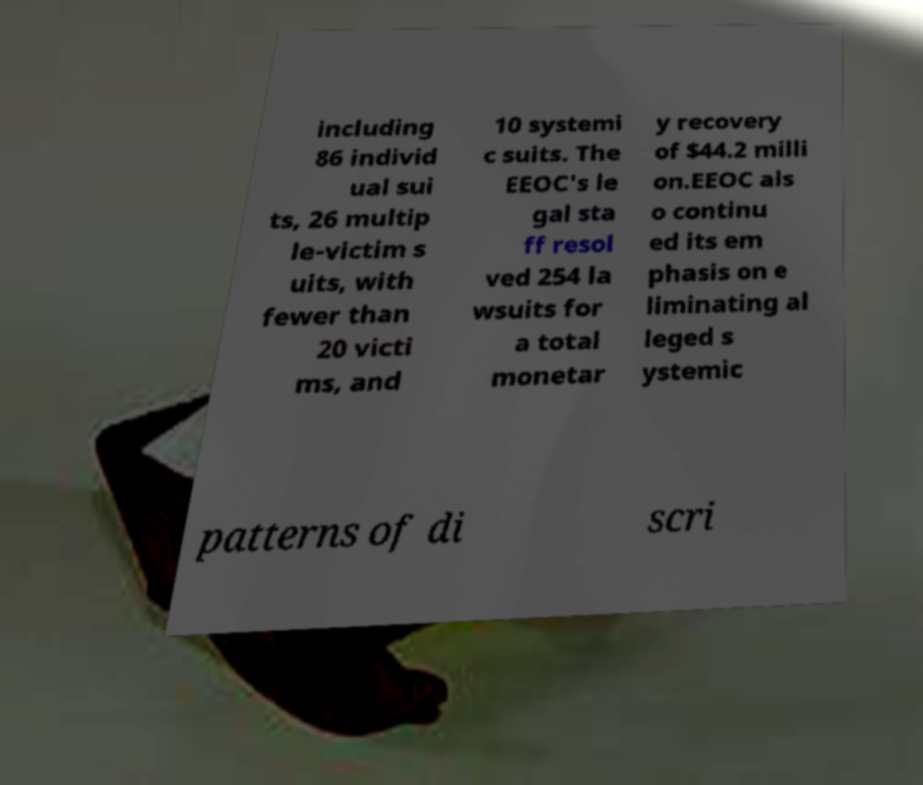I need the written content from this picture converted into text. Can you do that? including 86 individ ual sui ts, 26 multip le-victim s uits, with fewer than 20 victi ms, and 10 systemi c suits. The EEOC's le gal sta ff resol ved 254 la wsuits for a total monetar y recovery of $44.2 milli on.EEOC als o continu ed its em phasis on e liminating al leged s ystemic patterns of di scri 